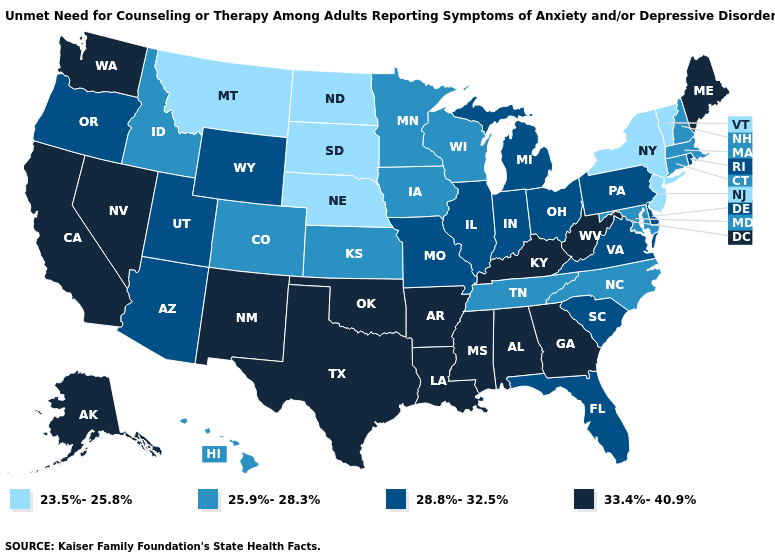Name the states that have a value in the range 25.9%-28.3%?
Quick response, please. Colorado, Connecticut, Hawaii, Idaho, Iowa, Kansas, Maryland, Massachusetts, Minnesota, New Hampshire, North Carolina, Tennessee, Wisconsin. What is the value of Alabama?
Keep it brief. 33.4%-40.9%. Name the states that have a value in the range 28.8%-32.5%?
Answer briefly. Arizona, Delaware, Florida, Illinois, Indiana, Michigan, Missouri, Ohio, Oregon, Pennsylvania, Rhode Island, South Carolina, Utah, Virginia, Wyoming. Does Wyoming have a higher value than West Virginia?
Keep it brief. No. Does Idaho have a higher value than North Dakota?
Keep it brief. Yes. Name the states that have a value in the range 28.8%-32.5%?
Concise answer only. Arizona, Delaware, Florida, Illinois, Indiana, Michigan, Missouri, Ohio, Oregon, Pennsylvania, Rhode Island, South Carolina, Utah, Virginia, Wyoming. Name the states that have a value in the range 25.9%-28.3%?
Concise answer only. Colorado, Connecticut, Hawaii, Idaho, Iowa, Kansas, Maryland, Massachusetts, Minnesota, New Hampshire, North Carolina, Tennessee, Wisconsin. What is the value of Idaho?
Keep it brief. 25.9%-28.3%. Name the states that have a value in the range 25.9%-28.3%?
Short answer required. Colorado, Connecticut, Hawaii, Idaho, Iowa, Kansas, Maryland, Massachusetts, Minnesota, New Hampshire, North Carolina, Tennessee, Wisconsin. What is the value of Indiana?
Be succinct. 28.8%-32.5%. Which states have the highest value in the USA?
Answer briefly. Alabama, Alaska, Arkansas, California, Georgia, Kentucky, Louisiana, Maine, Mississippi, Nevada, New Mexico, Oklahoma, Texas, Washington, West Virginia. What is the lowest value in the West?
Short answer required. 23.5%-25.8%. Among the states that border Illinois , which have the highest value?
Give a very brief answer. Kentucky. What is the highest value in the USA?
Short answer required. 33.4%-40.9%. What is the value of New Hampshire?
Give a very brief answer. 25.9%-28.3%. 